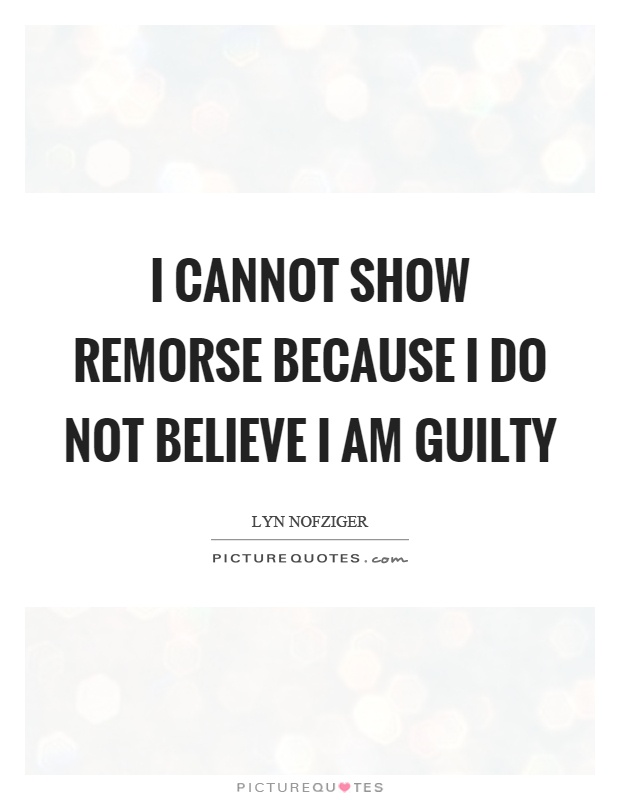How does the choice of background affect the perception of the quote in the image? The soft, blurred background in the image serves to focus the viewer's attention squarely on the text of the quote. This absence of distraction enhances the contemplative nature of the quote, suggesting a tranquil or pensive mood which aligns with the reflective content of the text. The neutral colors also ensure that the quote remains the central point of interest, reinforcing the message's gravity and introspective quality. 